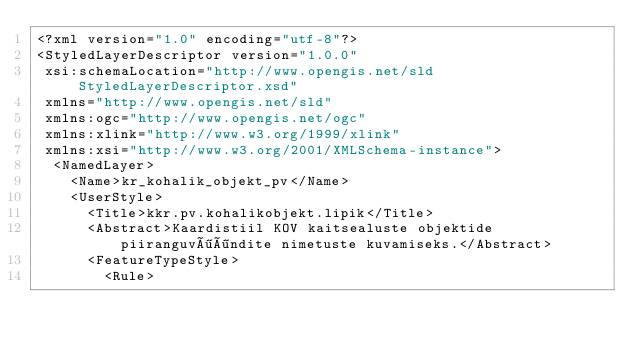<code> <loc_0><loc_0><loc_500><loc_500><_Scheme_><?xml version="1.0" encoding="utf-8"?>
<StyledLayerDescriptor version="1.0.0" 
 xsi:schemaLocation="http://www.opengis.net/sld StyledLayerDescriptor.xsd" 
 xmlns="http://www.opengis.net/sld" 
 xmlns:ogc="http://www.opengis.net/ogc" 
 xmlns:xlink="http://www.w3.org/1999/xlink" 
 xmlns:xsi="http://www.w3.org/2001/XMLSchema-instance">
  <NamedLayer>
    <Name>kr_kohalik_objekt_pv</Name>
    <UserStyle>
      <Title>kkr.pv.kohalikobjekt.lipik</Title>
      <Abstract>Kaardistiil KOV kaitsealuste objektide piiranguvööndite nimetuste kuvamiseks.</Abstract>
      <FeatureTypeStyle>
        <Rule></code> 